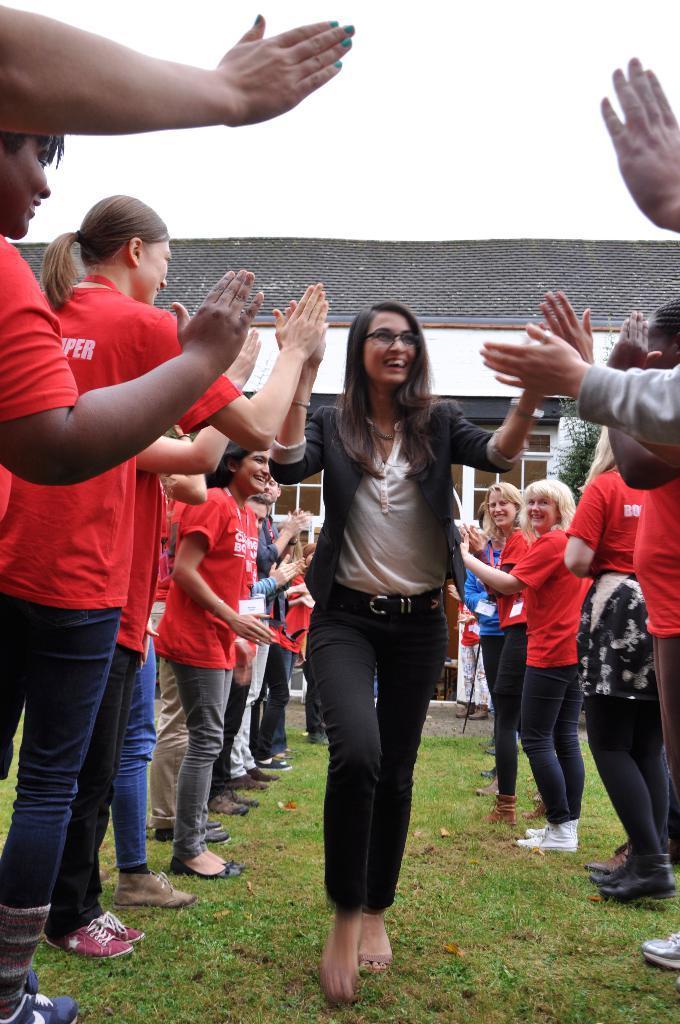Can you describe this image briefly? Here we can see a crowd. Land is covered with grass. Background there is a house with glass windows. 